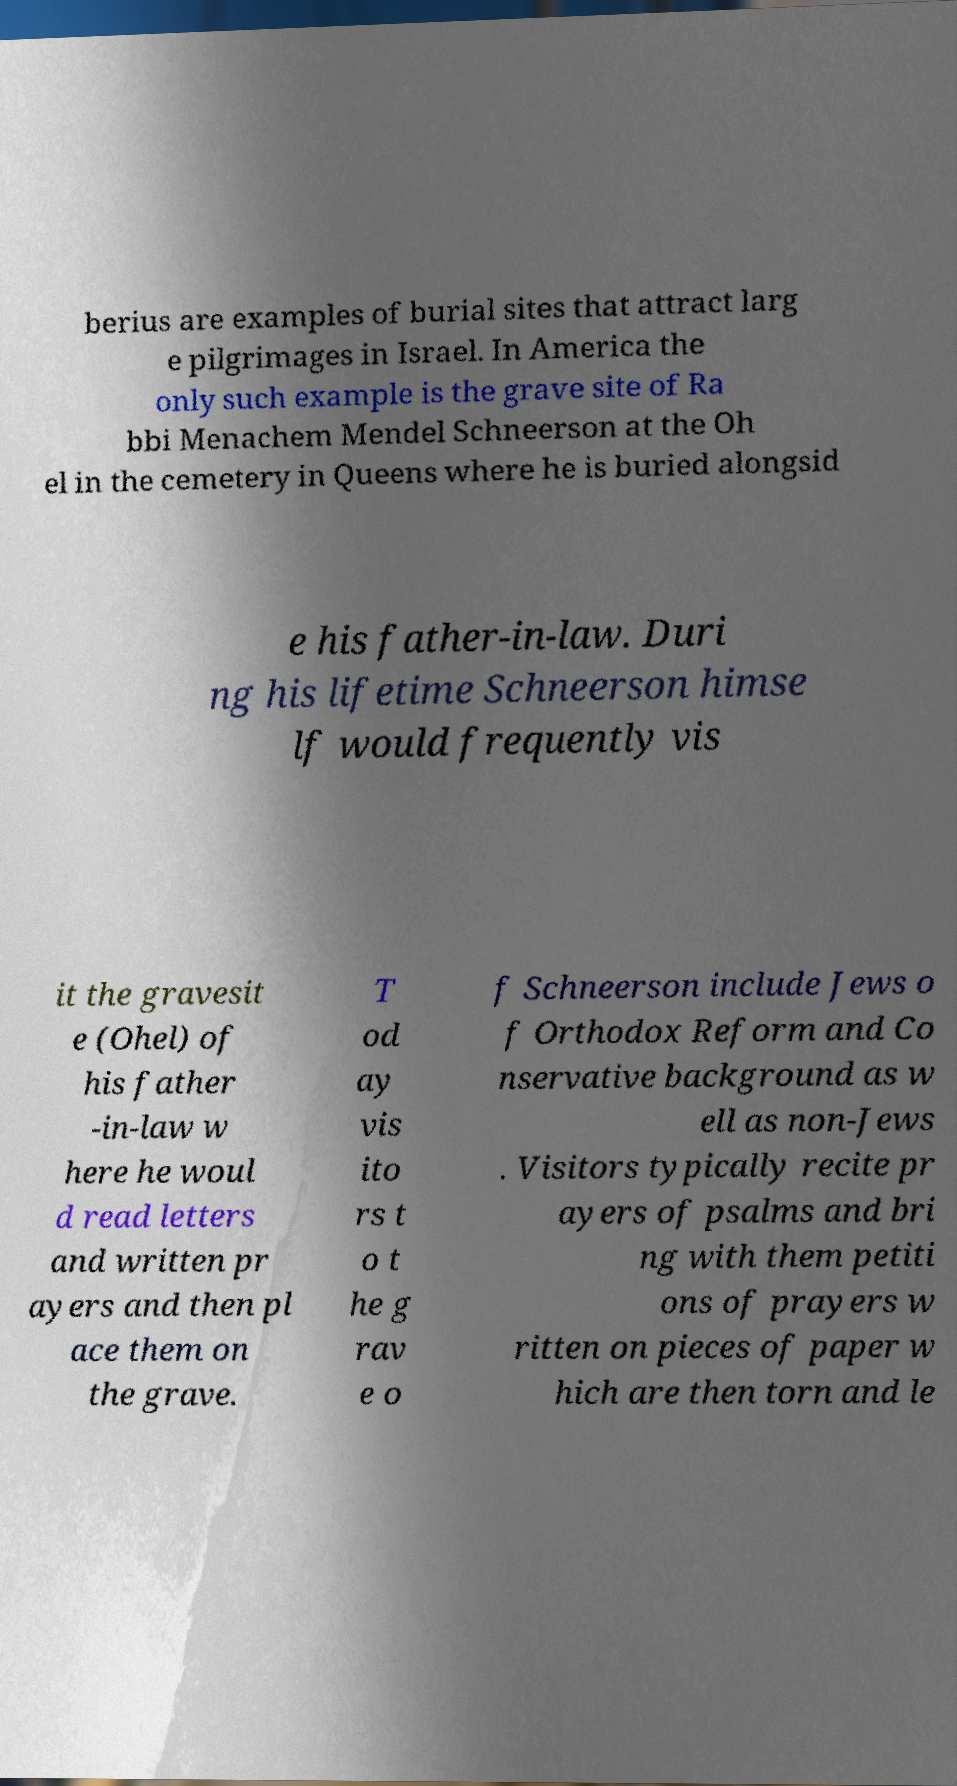Please read and relay the text visible in this image. What does it say? berius are examples of burial sites that attract larg e pilgrimages in Israel. In America the only such example is the grave site of Ra bbi Menachem Mendel Schneerson at the Oh el in the cemetery in Queens where he is buried alongsid e his father-in-law. Duri ng his lifetime Schneerson himse lf would frequently vis it the gravesit e (Ohel) of his father -in-law w here he woul d read letters and written pr ayers and then pl ace them on the grave. T od ay vis ito rs t o t he g rav e o f Schneerson include Jews o f Orthodox Reform and Co nservative background as w ell as non-Jews . Visitors typically recite pr ayers of psalms and bri ng with them petiti ons of prayers w ritten on pieces of paper w hich are then torn and le 